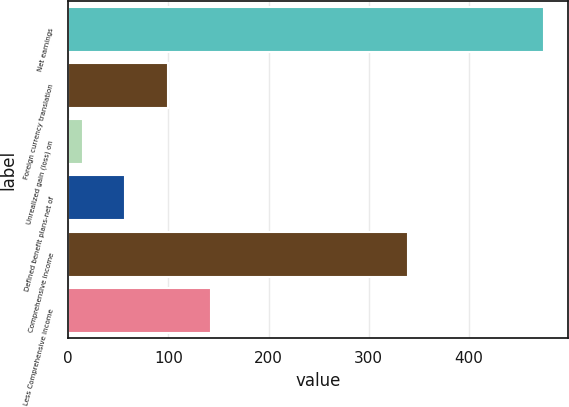Convert chart. <chart><loc_0><loc_0><loc_500><loc_500><bar_chart><fcel>Net earnings<fcel>Foreign currency translation<fcel>Unrealized gain (loss) on<fcel>Defined benefit plans-net of<fcel>Comprehensive income<fcel>Less Comprehensive income<nl><fcel>474.61<fcel>99.82<fcel>14.6<fcel>57.21<fcel>339.1<fcel>142.43<nl></chart> 